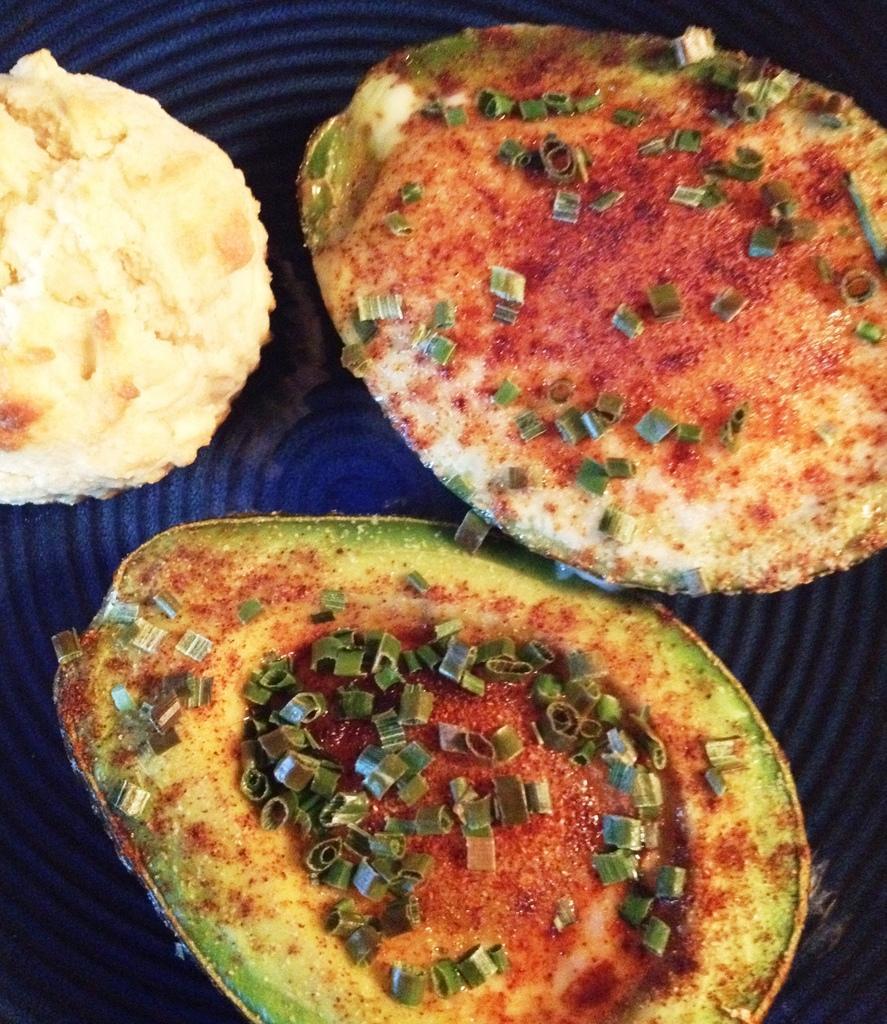In one or two sentences, can you explain what this image depicts? In this image I can see a cookie, kiwi and a food item in a plate. This image is taken may be in a room. 